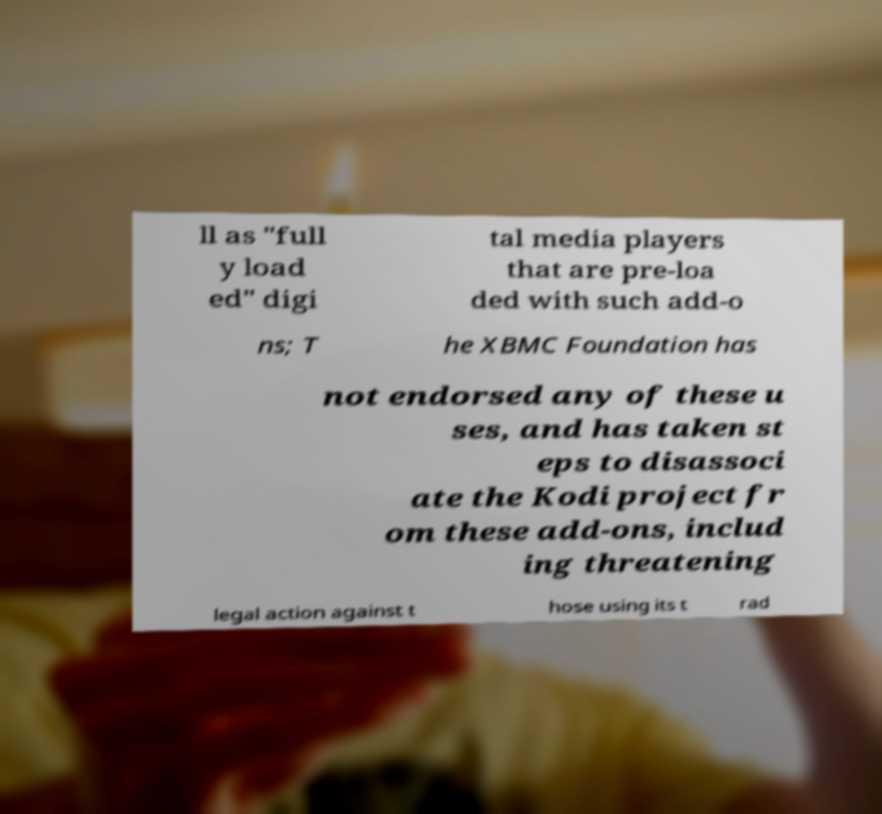For documentation purposes, I need the text within this image transcribed. Could you provide that? ll as "full y load ed" digi tal media players that are pre-loa ded with such add-o ns; T he XBMC Foundation has not endorsed any of these u ses, and has taken st eps to disassoci ate the Kodi project fr om these add-ons, includ ing threatening legal action against t hose using its t rad 